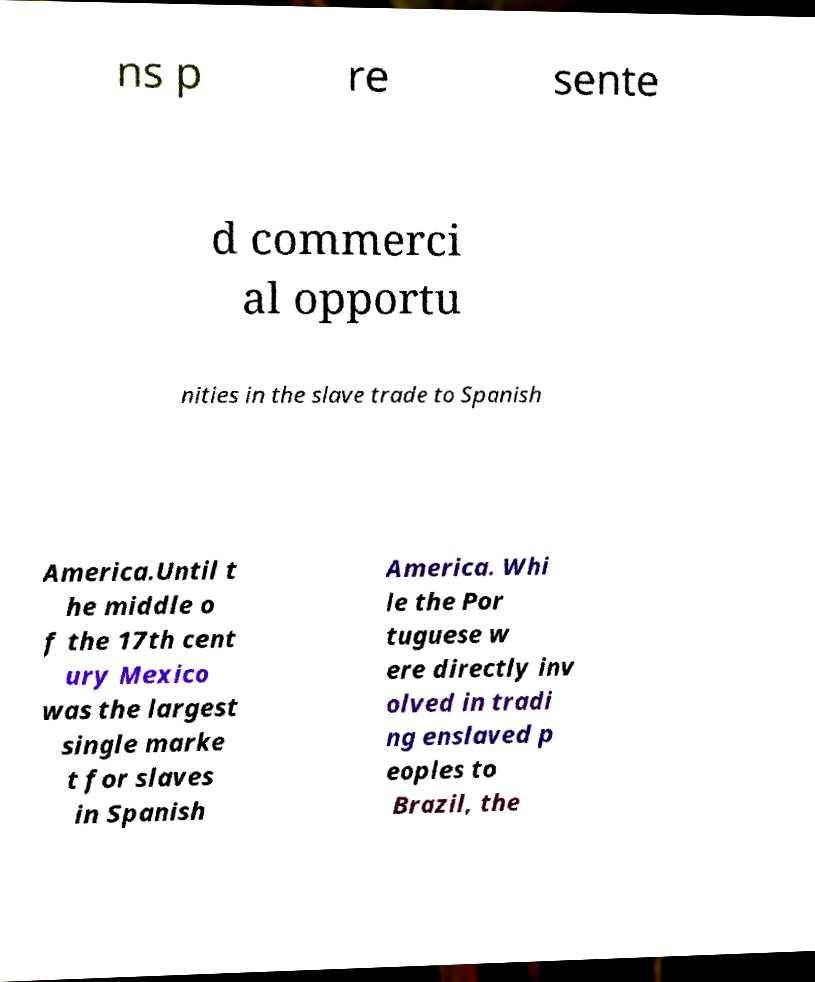Please read and relay the text visible in this image. What does it say? ns p re sente d commerci al opportu nities in the slave trade to Spanish America.Until t he middle o f the 17th cent ury Mexico was the largest single marke t for slaves in Spanish America. Whi le the Por tuguese w ere directly inv olved in tradi ng enslaved p eoples to Brazil, the 